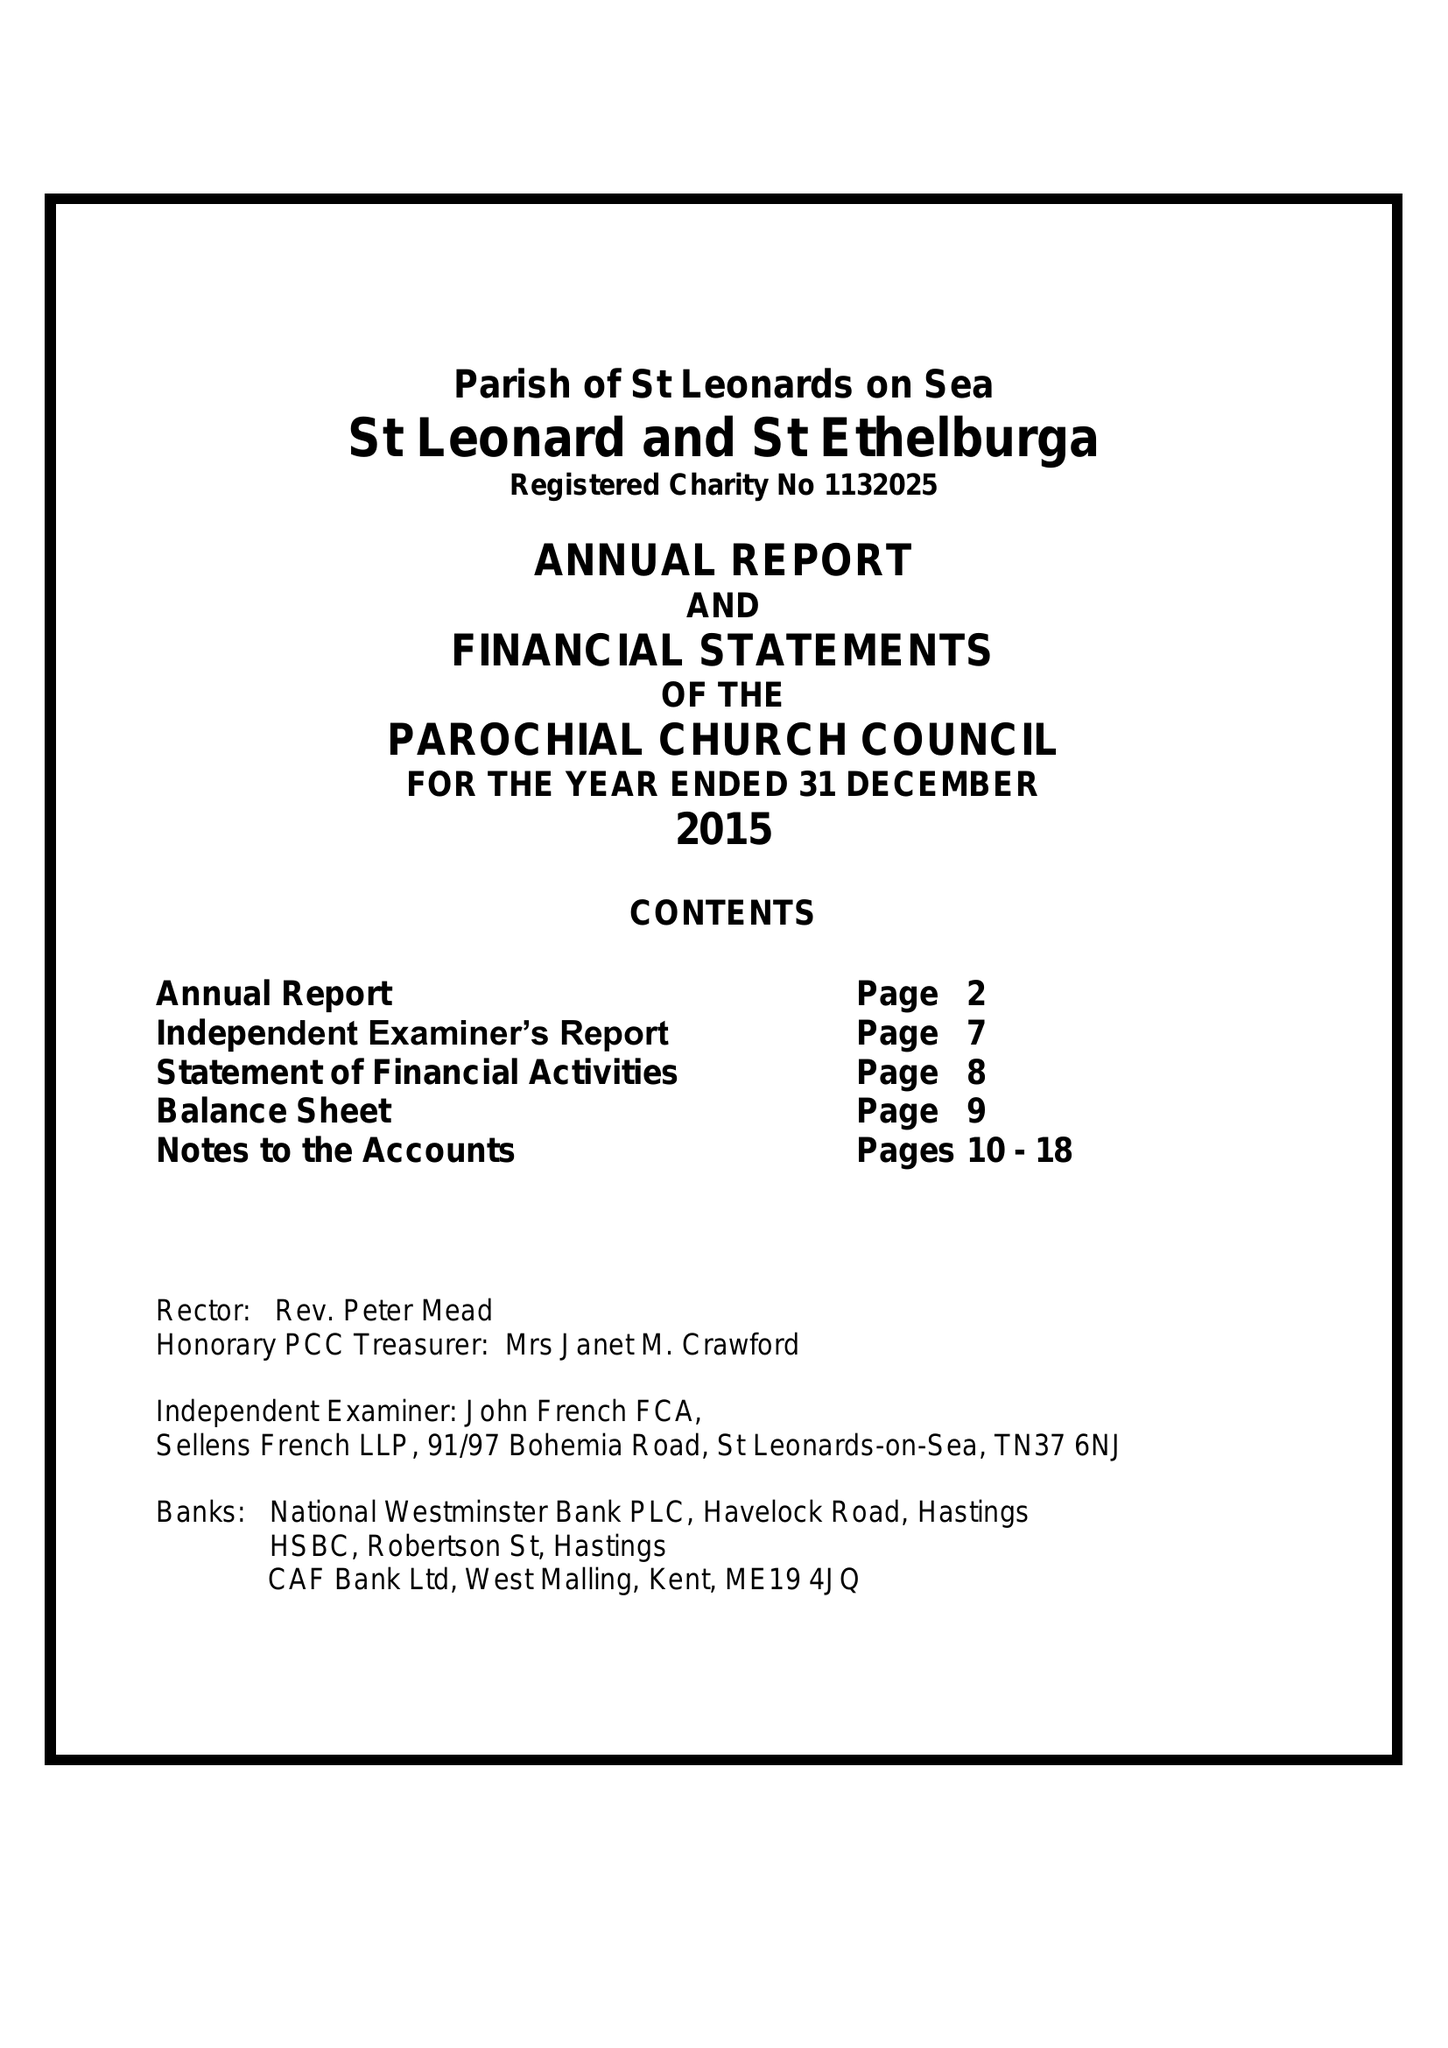What is the value for the address__street_line?
Answer the question using a single word or phrase. 130 SEDLESCOMBE GARDENS 